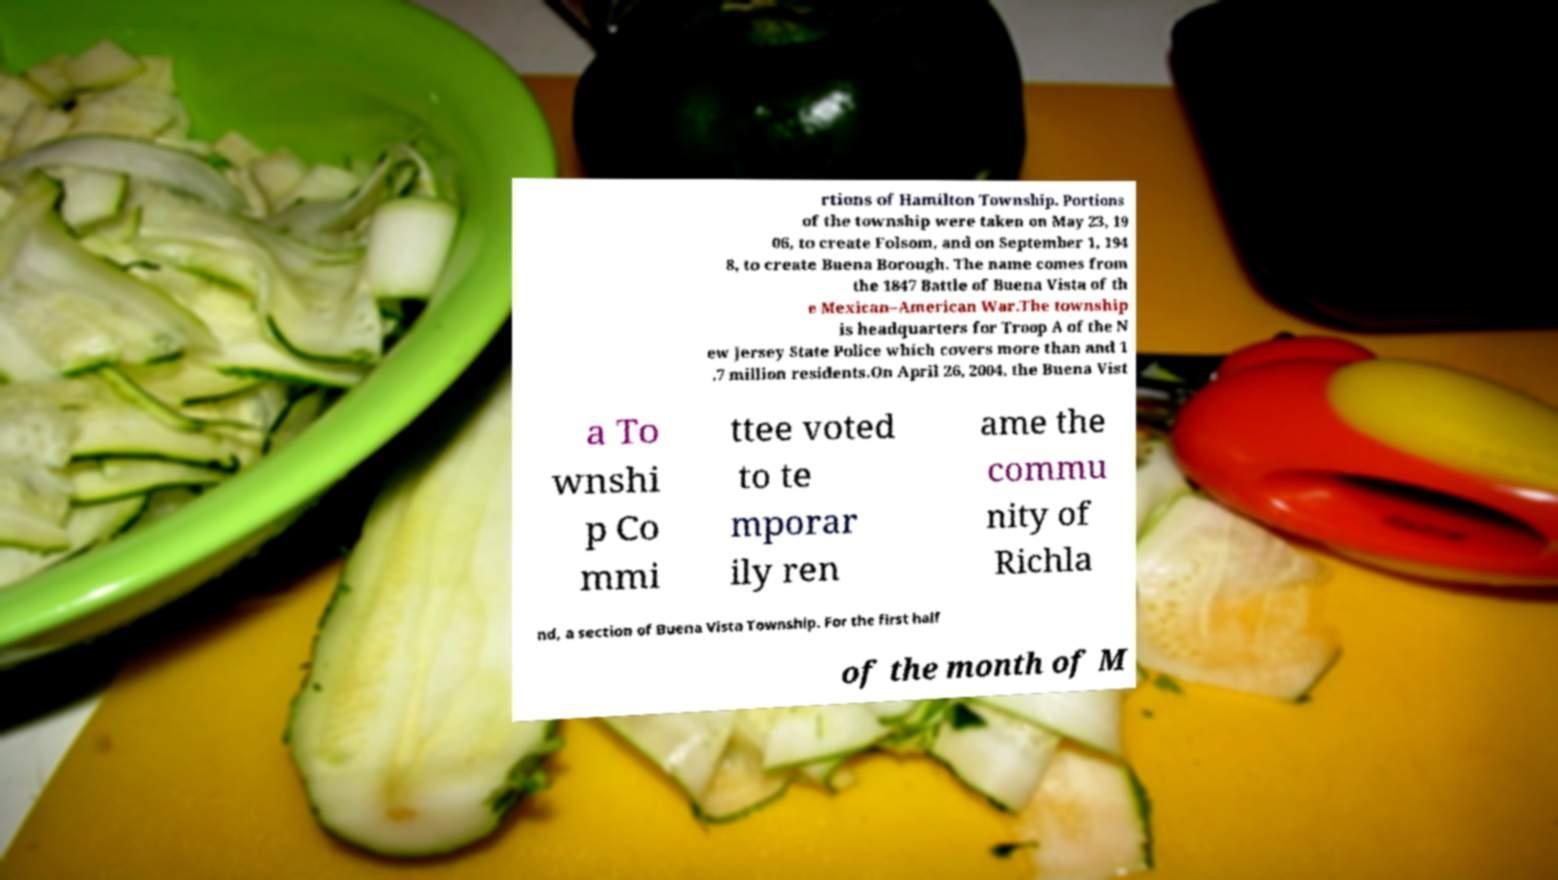Can you accurately transcribe the text from the provided image for me? rtions of Hamilton Township. Portions of the township were taken on May 23, 19 06, to create Folsom, and on September 1, 194 8, to create Buena Borough. The name comes from the 1847 Battle of Buena Vista of th e Mexican–American War.The township is headquarters for Troop A of the N ew Jersey State Police which covers more than and 1 .7 million residents.On April 26, 2004, the Buena Vist a To wnshi p Co mmi ttee voted to te mporar ily ren ame the commu nity of Richla nd, a section of Buena Vista Township. For the first half of the month of M 